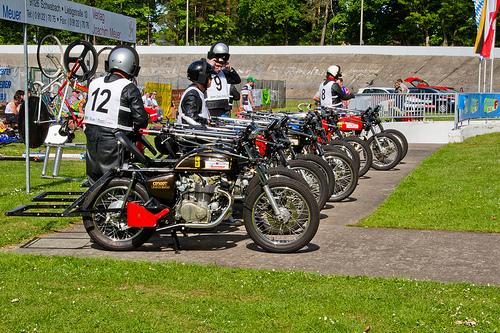Mention a detail about the shirt worn by the person with the number 12 on it. The person with the number 12 on their shirt is wearing a white vest. What is the color and material of the fence mentioned in the descriptions? The fence is silver and made of metal. Describe an object in the background that is not related to motorcycles. There are three different flags behind the grass at the top right corner of the image. What color is the helmet on the man at the left side of the image? The helmet on the man at the left side of the image is gray. How many flags can be seen in total in the image and what colors are they? In total, there are ten flags with colors red, white, black, and yellow. Based on the descriptions, what are some colors and patterns of various helmets present in the image? There are gray, black, silver, and white helmets with black and grey silver patterns. Which type of activities involving people are depicted in the picture? People wearing helmets, with one rider taking off a motorcycle helmet, and others standing behind a fence. List some objects found in the background of the image. There are trees, flags, a wall, a metal fence, people, and a sign held up by poles. Can you count the number of motorcycles in a row mentioned in the descriptions? There is a row of ten motorcycles. Tell me something distinctive about the landscape in this image. There is a patch of green grass and a cement path running through it. Analyze the interactions between objects in the image. Men are wearing helmets, and riders are taking off helmets near the row of motorcycles. Are the bikes all lined up on the grassy area? The bikes are lined up, but they're not mentioned to be specifically on the grassy area. A separate grassy area, cement path, and sidewalk are mentioned, but their relationship to the bikes' positions isn't specified. Can you identify any emotions or feelings associated with this image? Excitement, anticipation, busy atmosphere How many people are standing behind the fence? three people Locate the description that corresponds to the person with the number 12 on their back. white vest with 12 on it X:85 Y:74 Width:48 Height:48 Are there any animals behind the orange fence? The fence is described as silver metal and not orange. Also, there are people and trees mentioned behind the fence but no animals. Locate the description of the black and grey silver helmet. black and grey silver helmet X:106 Y:42 Width:33 Height:33 Is there any writing on the blue and white coat? The coat described is black and white, not blue and white. What type of equipment do the bikers wear for protection? helmets Read the number on the back of the white vest. 12 Determine the emotions or sentiment exhibited by the three different flags mentioned in the image. The sentiment is neutral - flags do not convey emotions. List the numbers associated with the different bike riders in this image. 8, 9, and 12. Can you see the number 5 on the person's back next to the person wearing a vest with number 12 on it? There's no mention of a number 5 on anyone's back in the list of objects. Only numbers 12, 9, and 8 are mentioned. Identify any unusual elements in the image. There are no significant anomalies in the content of the image. Does the red helmet on the man have a scratch on it? There is no red helmet mentioned in the list of objects, only gray, silver, black, and white helmets. Is there a rainbow flag among the three different flags in the far left of the image? There's no mention of a rainbow flag. The flags described are red, white, black, and yellow, with no information on their arrangement. What colors are present on the flags behind the grass? Red, white, black, and yellow What is the color of the fence in the image? Silver List the different types of helmets mentioned in the image. gray helmet, black helmet, white helmet, silver motorcycle helmet What is visible behind the motorcycles? flags, trees, and a wall Identify the type of surrounding around the motorcycles. sidewalk, grass, trees, and fence Describe the scene with the most important objects. There is a row of motorcycles, men wearing helmets, a grassy area, people behind a fence, and trees in the background. Choose the correct statement: a) There are more than ten motorcycles, b) There are exactly ten motorcycles, c) There are less than ten motorcycles b) There are exactly ten motorcycles 